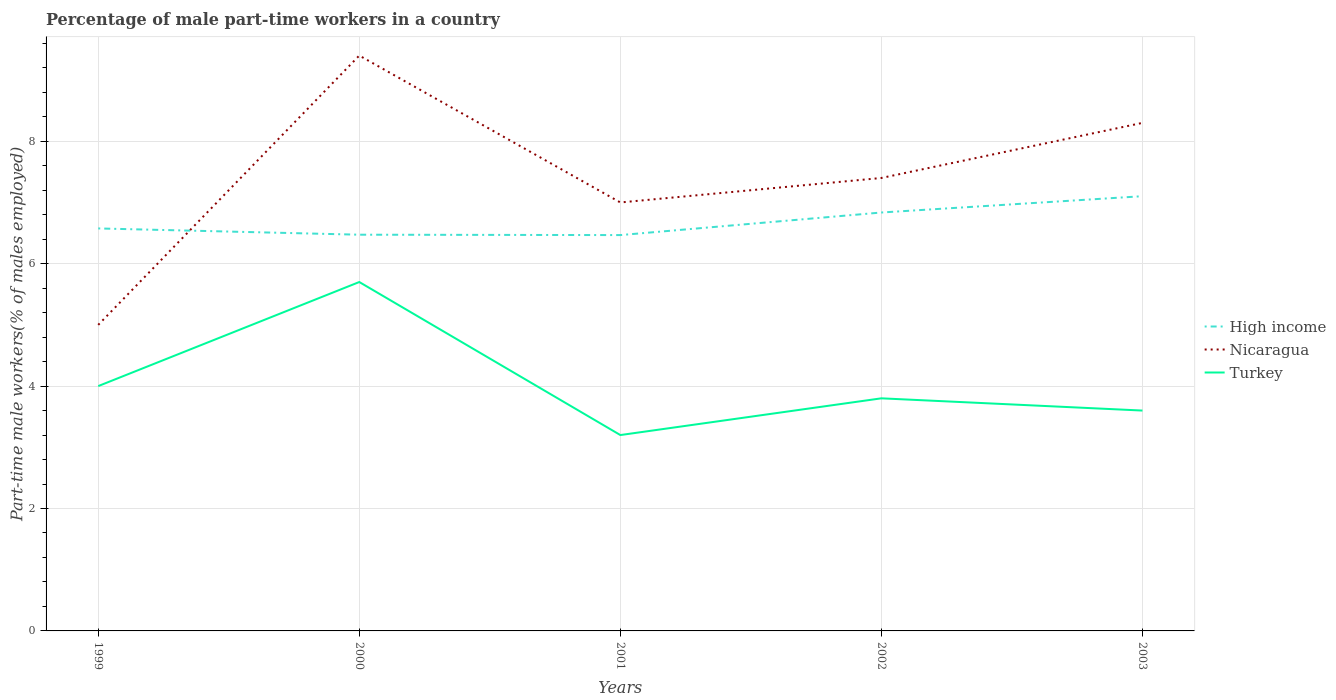Across all years, what is the maximum percentage of male part-time workers in High income?
Your response must be concise. 6.47. In which year was the percentage of male part-time workers in Turkey maximum?
Ensure brevity in your answer.  2001. What is the total percentage of male part-time workers in Nicaragua in the graph?
Offer a terse response. -4.4. What is the difference between the highest and the second highest percentage of male part-time workers in High income?
Offer a terse response. 0.64. What is the difference between the highest and the lowest percentage of male part-time workers in Nicaragua?
Your answer should be very brief. 2. Is the percentage of male part-time workers in Turkey strictly greater than the percentage of male part-time workers in High income over the years?
Offer a terse response. Yes. Does the graph contain grids?
Your response must be concise. Yes. How are the legend labels stacked?
Give a very brief answer. Vertical. What is the title of the graph?
Provide a short and direct response. Percentage of male part-time workers in a country. What is the label or title of the X-axis?
Keep it short and to the point. Years. What is the label or title of the Y-axis?
Your answer should be compact. Part-time male workers(% of males employed). What is the Part-time male workers(% of males employed) in High income in 1999?
Your answer should be very brief. 6.58. What is the Part-time male workers(% of males employed) of Turkey in 1999?
Provide a succinct answer. 4. What is the Part-time male workers(% of males employed) in High income in 2000?
Offer a very short reply. 6.47. What is the Part-time male workers(% of males employed) of Nicaragua in 2000?
Offer a very short reply. 9.4. What is the Part-time male workers(% of males employed) in Turkey in 2000?
Offer a very short reply. 5.7. What is the Part-time male workers(% of males employed) in High income in 2001?
Offer a terse response. 6.47. What is the Part-time male workers(% of males employed) of Nicaragua in 2001?
Offer a terse response. 7. What is the Part-time male workers(% of males employed) in Turkey in 2001?
Make the answer very short. 3.2. What is the Part-time male workers(% of males employed) in High income in 2002?
Make the answer very short. 6.84. What is the Part-time male workers(% of males employed) of Nicaragua in 2002?
Make the answer very short. 7.4. What is the Part-time male workers(% of males employed) of Turkey in 2002?
Keep it short and to the point. 3.8. What is the Part-time male workers(% of males employed) of High income in 2003?
Offer a very short reply. 7.1. What is the Part-time male workers(% of males employed) of Nicaragua in 2003?
Make the answer very short. 8.3. What is the Part-time male workers(% of males employed) in Turkey in 2003?
Keep it short and to the point. 3.6. Across all years, what is the maximum Part-time male workers(% of males employed) in High income?
Provide a short and direct response. 7.1. Across all years, what is the maximum Part-time male workers(% of males employed) in Nicaragua?
Offer a terse response. 9.4. Across all years, what is the maximum Part-time male workers(% of males employed) of Turkey?
Keep it short and to the point. 5.7. Across all years, what is the minimum Part-time male workers(% of males employed) of High income?
Offer a very short reply. 6.47. Across all years, what is the minimum Part-time male workers(% of males employed) of Turkey?
Offer a terse response. 3.2. What is the total Part-time male workers(% of males employed) in High income in the graph?
Your answer should be compact. 33.45. What is the total Part-time male workers(% of males employed) in Nicaragua in the graph?
Offer a very short reply. 37.1. What is the total Part-time male workers(% of males employed) of Turkey in the graph?
Your answer should be compact. 20.3. What is the difference between the Part-time male workers(% of males employed) in High income in 1999 and that in 2000?
Give a very brief answer. 0.1. What is the difference between the Part-time male workers(% of males employed) of Nicaragua in 1999 and that in 2000?
Provide a succinct answer. -4.4. What is the difference between the Part-time male workers(% of males employed) in High income in 1999 and that in 2001?
Offer a very short reply. 0.11. What is the difference between the Part-time male workers(% of males employed) of Nicaragua in 1999 and that in 2001?
Provide a succinct answer. -2. What is the difference between the Part-time male workers(% of males employed) in Turkey in 1999 and that in 2001?
Provide a short and direct response. 0.8. What is the difference between the Part-time male workers(% of males employed) of High income in 1999 and that in 2002?
Keep it short and to the point. -0.26. What is the difference between the Part-time male workers(% of males employed) of Turkey in 1999 and that in 2002?
Your response must be concise. 0.2. What is the difference between the Part-time male workers(% of males employed) in High income in 1999 and that in 2003?
Provide a short and direct response. -0.53. What is the difference between the Part-time male workers(% of males employed) of High income in 2000 and that in 2001?
Keep it short and to the point. 0.01. What is the difference between the Part-time male workers(% of males employed) in Turkey in 2000 and that in 2001?
Your answer should be compact. 2.5. What is the difference between the Part-time male workers(% of males employed) in High income in 2000 and that in 2002?
Your response must be concise. -0.36. What is the difference between the Part-time male workers(% of males employed) in Nicaragua in 2000 and that in 2002?
Provide a short and direct response. 2. What is the difference between the Part-time male workers(% of males employed) of Turkey in 2000 and that in 2002?
Your response must be concise. 1.9. What is the difference between the Part-time male workers(% of males employed) in High income in 2000 and that in 2003?
Make the answer very short. -0.63. What is the difference between the Part-time male workers(% of males employed) of Turkey in 2000 and that in 2003?
Your answer should be very brief. 2.1. What is the difference between the Part-time male workers(% of males employed) in High income in 2001 and that in 2002?
Keep it short and to the point. -0.37. What is the difference between the Part-time male workers(% of males employed) in Nicaragua in 2001 and that in 2002?
Offer a very short reply. -0.4. What is the difference between the Part-time male workers(% of males employed) in High income in 2001 and that in 2003?
Your answer should be compact. -0.64. What is the difference between the Part-time male workers(% of males employed) in Nicaragua in 2001 and that in 2003?
Ensure brevity in your answer.  -1.3. What is the difference between the Part-time male workers(% of males employed) in Turkey in 2001 and that in 2003?
Offer a very short reply. -0.4. What is the difference between the Part-time male workers(% of males employed) in High income in 2002 and that in 2003?
Your answer should be compact. -0.27. What is the difference between the Part-time male workers(% of males employed) in Turkey in 2002 and that in 2003?
Offer a terse response. 0.2. What is the difference between the Part-time male workers(% of males employed) in High income in 1999 and the Part-time male workers(% of males employed) in Nicaragua in 2000?
Your response must be concise. -2.82. What is the difference between the Part-time male workers(% of males employed) of High income in 1999 and the Part-time male workers(% of males employed) of Turkey in 2000?
Give a very brief answer. 0.88. What is the difference between the Part-time male workers(% of males employed) in High income in 1999 and the Part-time male workers(% of males employed) in Nicaragua in 2001?
Offer a terse response. -0.42. What is the difference between the Part-time male workers(% of males employed) of High income in 1999 and the Part-time male workers(% of males employed) of Turkey in 2001?
Make the answer very short. 3.38. What is the difference between the Part-time male workers(% of males employed) in Nicaragua in 1999 and the Part-time male workers(% of males employed) in Turkey in 2001?
Give a very brief answer. 1.8. What is the difference between the Part-time male workers(% of males employed) in High income in 1999 and the Part-time male workers(% of males employed) in Nicaragua in 2002?
Offer a very short reply. -0.82. What is the difference between the Part-time male workers(% of males employed) of High income in 1999 and the Part-time male workers(% of males employed) of Turkey in 2002?
Your answer should be compact. 2.78. What is the difference between the Part-time male workers(% of males employed) of Nicaragua in 1999 and the Part-time male workers(% of males employed) of Turkey in 2002?
Provide a short and direct response. 1.2. What is the difference between the Part-time male workers(% of males employed) in High income in 1999 and the Part-time male workers(% of males employed) in Nicaragua in 2003?
Your answer should be compact. -1.72. What is the difference between the Part-time male workers(% of males employed) of High income in 1999 and the Part-time male workers(% of males employed) of Turkey in 2003?
Make the answer very short. 2.98. What is the difference between the Part-time male workers(% of males employed) in Nicaragua in 1999 and the Part-time male workers(% of males employed) in Turkey in 2003?
Offer a very short reply. 1.4. What is the difference between the Part-time male workers(% of males employed) in High income in 2000 and the Part-time male workers(% of males employed) in Nicaragua in 2001?
Keep it short and to the point. -0.53. What is the difference between the Part-time male workers(% of males employed) of High income in 2000 and the Part-time male workers(% of males employed) of Turkey in 2001?
Your answer should be very brief. 3.27. What is the difference between the Part-time male workers(% of males employed) in Nicaragua in 2000 and the Part-time male workers(% of males employed) in Turkey in 2001?
Your answer should be compact. 6.2. What is the difference between the Part-time male workers(% of males employed) in High income in 2000 and the Part-time male workers(% of males employed) in Nicaragua in 2002?
Offer a terse response. -0.93. What is the difference between the Part-time male workers(% of males employed) in High income in 2000 and the Part-time male workers(% of males employed) in Turkey in 2002?
Your response must be concise. 2.67. What is the difference between the Part-time male workers(% of males employed) in Nicaragua in 2000 and the Part-time male workers(% of males employed) in Turkey in 2002?
Your answer should be very brief. 5.6. What is the difference between the Part-time male workers(% of males employed) in High income in 2000 and the Part-time male workers(% of males employed) in Nicaragua in 2003?
Offer a very short reply. -1.83. What is the difference between the Part-time male workers(% of males employed) in High income in 2000 and the Part-time male workers(% of males employed) in Turkey in 2003?
Ensure brevity in your answer.  2.87. What is the difference between the Part-time male workers(% of males employed) of Nicaragua in 2000 and the Part-time male workers(% of males employed) of Turkey in 2003?
Your answer should be compact. 5.8. What is the difference between the Part-time male workers(% of males employed) of High income in 2001 and the Part-time male workers(% of males employed) of Nicaragua in 2002?
Your answer should be very brief. -0.93. What is the difference between the Part-time male workers(% of males employed) in High income in 2001 and the Part-time male workers(% of males employed) in Turkey in 2002?
Ensure brevity in your answer.  2.67. What is the difference between the Part-time male workers(% of males employed) of Nicaragua in 2001 and the Part-time male workers(% of males employed) of Turkey in 2002?
Offer a terse response. 3.2. What is the difference between the Part-time male workers(% of males employed) of High income in 2001 and the Part-time male workers(% of males employed) of Nicaragua in 2003?
Provide a succinct answer. -1.83. What is the difference between the Part-time male workers(% of males employed) of High income in 2001 and the Part-time male workers(% of males employed) of Turkey in 2003?
Offer a very short reply. 2.87. What is the difference between the Part-time male workers(% of males employed) in High income in 2002 and the Part-time male workers(% of males employed) in Nicaragua in 2003?
Your response must be concise. -1.46. What is the difference between the Part-time male workers(% of males employed) in High income in 2002 and the Part-time male workers(% of males employed) in Turkey in 2003?
Keep it short and to the point. 3.24. What is the difference between the Part-time male workers(% of males employed) of Nicaragua in 2002 and the Part-time male workers(% of males employed) of Turkey in 2003?
Ensure brevity in your answer.  3.8. What is the average Part-time male workers(% of males employed) in High income per year?
Offer a very short reply. 6.69. What is the average Part-time male workers(% of males employed) of Nicaragua per year?
Ensure brevity in your answer.  7.42. What is the average Part-time male workers(% of males employed) of Turkey per year?
Offer a terse response. 4.06. In the year 1999, what is the difference between the Part-time male workers(% of males employed) of High income and Part-time male workers(% of males employed) of Nicaragua?
Your response must be concise. 1.58. In the year 1999, what is the difference between the Part-time male workers(% of males employed) in High income and Part-time male workers(% of males employed) in Turkey?
Your answer should be very brief. 2.58. In the year 2000, what is the difference between the Part-time male workers(% of males employed) in High income and Part-time male workers(% of males employed) in Nicaragua?
Your answer should be compact. -2.93. In the year 2000, what is the difference between the Part-time male workers(% of males employed) of High income and Part-time male workers(% of males employed) of Turkey?
Provide a short and direct response. 0.77. In the year 2001, what is the difference between the Part-time male workers(% of males employed) in High income and Part-time male workers(% of males employed) in Nicaragua?
Keep it short and to the point. -0.53. In the year 2001, what is the difference between the Part-time male workers(% of males employed) in High income and Part-time male workers(% of males employed) in Turkey?
Your answer should be compact. 3.27. In the year 2001, what is the difference between the Part-time male workers(% of males employed) of Nicaragua and Part-time male workers(% of males employed) of Turkey?
Ensure brevity in your answer.  3.8. In the year 2002, what is the difference between the Part-time male workers(% of males employed) of High income and Part-time male workers(% of males employed) of Nicaragua?
Provide a succinct answer. -0.56. In the year 2002, what is the difference between the Part-time male workers(% of males employed) in High income and Part-time male workers(% of males employed) in Turkey?
Provide a succinct answer. 3.04. In the year 2003, what is the difference between the Part-time male workers(% of males employed) of High income and Part-time male workers(% of males employed) of Nicaragua?
Provide a succinct answer. -1.2. In the year 2003, what is the difference between the Part-time male workers(% of males employed) in High income and Part-time male workers(% of males employed) in Turkey?
Provide a short and direct response. 3.5. In the year 2003, what is the difference between the Part-time male workers(% of males employed) in Nicaragua and Part-time male workers(% of males employed) in Turkey?
Give a very brief answer. 4.7. What is the ratio of the Part-time male workers(% of males employed) of High income in 1999 to that in 2000?
Give a very brief answer. 1.02. What is the ratio of the Part-time male workers(% of males employed) of Nicaragua in 1999 to that in 2000?
Provide a succinct answer. 0.53. What is the ratio of the Part-time male workers(% of males employed) of Turkey in 1999 to that in 2000?
Give a very brief answer. 0.7. What is the ratio of the Part-time male workers(% of males employed) in High income in 1999 to that in 2001?
Give a very brief answer. 1.02. What is the ratio of the Part-time male workers(% of males employed) in High income in 1999 to that in 2002?
Offer a very short reply. 0.96. What is the ratio of the Part-time male workers(% of males employed) of Nicaragua in 1999 to that in 2002?
Offer a very short reply. 0.68. What is the ratio of the Part-time male workers(% of males employed) in Turkey in 1999 to that in 2002?
Keep it short and to the point. 1.05. What is the ratio of the Part-time male workers(% of males employed) of High income in 1999 to that in 2003?
Your answer should be compact. 0.93. What is the ratio of the Part-time male workers(% of males employed) in Nicaragua in 1999 to that in 2003?
Your response must be concise. 0.6. What is the ratio of the Part-time male workers(% of males employed) of Turkey in 1999 to that in 2003?
Provide a short and direct response. 1.11. What is the ratio of the Part-time male workers(% of males employed) in High income in 2000 to that in 2001?
Offer a very short reply. 1. What is the ratio of the Part-time male workers(% of males employed) in Nicaragua in 2000 to that in 2001?
Provide a succinct answer. 1.34. What is the ratio of the Part-time male workers(% of males employed) in Turkey in 2000 to that in 2001?
Keep it short and to the point. 1.78. What is the ratio of the Part-time male workers(% of males employed) of High income in 2000 to that in 2002?
Provide a succinct answer. 0.95. What is the ratio of the Part-time male workers(% of males employed) in Nicaragua in 2000 to that in 2002?
Provide a short and direct response. 1.27. What is the ratio of the Part-time male workers(% of males employed) of High income in 2000 to that in 2003?
Your answer should be very brief. 0.91. What is the ratio of the Part-time male workers(% of males employed) of Nicaragua in 2000 to that in 2003?
Offer a terse response. 1.13. What is the ratio of the Part-time male workers(% of males employed) of Turkey in 2000 to that in 2003?
Give a very brief answer. 1.58. What is the ratio of the Part-time male workers(% of males employed) in High income in 2001 to that in 2002?
Give a very brief answer. 0.95. What is the ratio of the Part-time male workers(% of males employed) of Nicaragua in 2001 to that in 2002?
Offer a terse response. 0.95. What is the ratio of the Part-time male workers(% of males employed) in Turkey in 2001 to that in 2002?
Your answer should be very brief. 0.84. What is the ratio of the Part-time male workers(% of males employed) of High income in 2001 to that in 2003?
Keep it short and to the point. 0.91. What is the ratio of the Part-time male workers(% of males employed) of Nicaragua in 2001 to that in 2003?
Provide a succinct answer. 0.84. What is the ratio of the Part-time male workers(% of males employed) of High income in 2002 to that in 2003?
Your response must be concise. 0.96. What is the ratio of the Part-time male workers(% of males employed) of Nicaragua in 2002 to that in 2003?
Offer a very short reply. 0.89. What is the ratio of the Part-time male workers(% of males employed) in Turkey in 2002 to that in 2003?
Give a very brief answer. 1.06. What is the difference between the highest and the second highest Part-time male workers(% of males employed) in High income?
Make the answer very short. 0.27. What is the difference between the highest and the second highest Part-time male workers(% of males employed) of Nicaragua?
Provide a short and direct response. 1.1. What is the difference between the highest and the lowest Part-time male workers(% of males employed) of High income?
Make the answer very short. 0.64. 